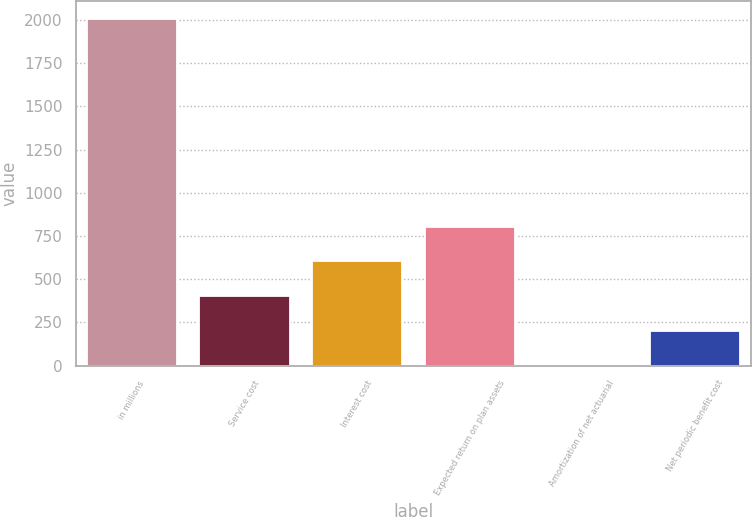Convert chart to OTSL. <chart><loc_0><loc_0><loc_500><loc_500><bar_chart><fcel>in millions<fcel>Service cost<fcel>Interest cost<fcel>Expected return on plan assets<fcel>Amortization of net actuarial<fcel>Net periodic benefit cost<nl><fcel>2007<fcel>402.92<fcel>603.43<fcel>803.94<fcel>1.9<fcel>202.41<nl></chart> 